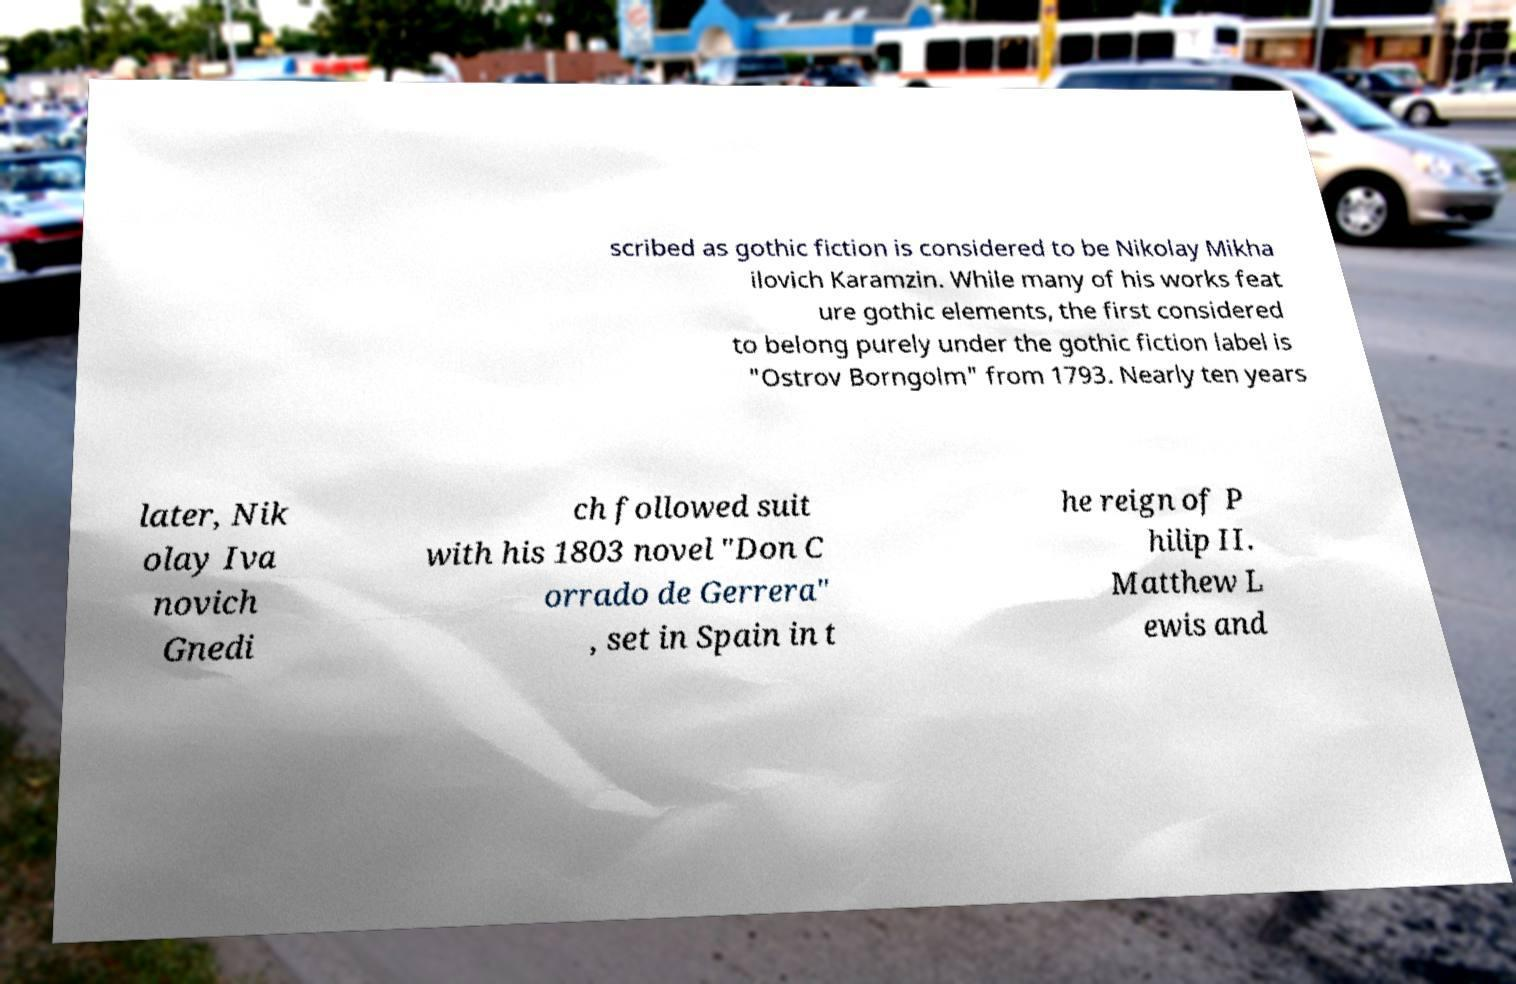Could you extract and type out the text from this image? scribed as gothic fiction is considered to be Nikolay Mikha ilovich Karamzin. While many of his works feat ure gothic elements, the first considered to belong purely under the gothic fiction label is "Ostrov Borngolm" from 1793. Nearly ten years later, Nik olay Iva novich Gnedi ch followed suit with his 1803 novel "Don C orrado de Gerrera" , set in Spain in t he reign of P hilip II. Matthew L ewis and 